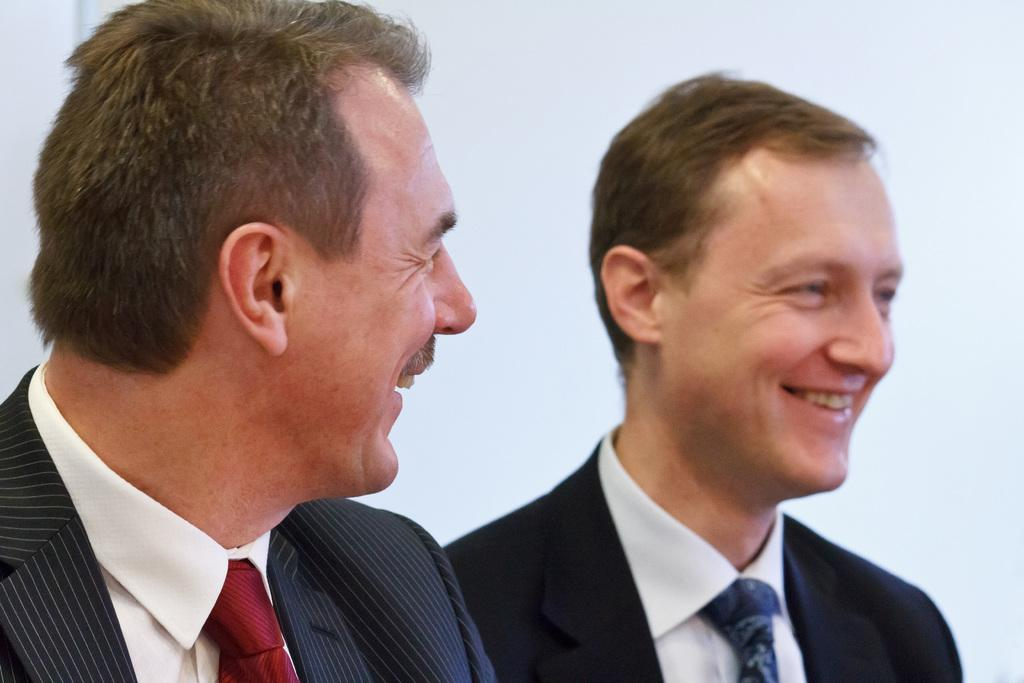How many people are in the image? There are two persons in the image. What expressions do the people have? Both persons have smiling faces. What color is the background of the image? The background of the image is white. What type of theory is being discussed by the persons in the image? There is no indication in the image that the persons are discussing any theories. 